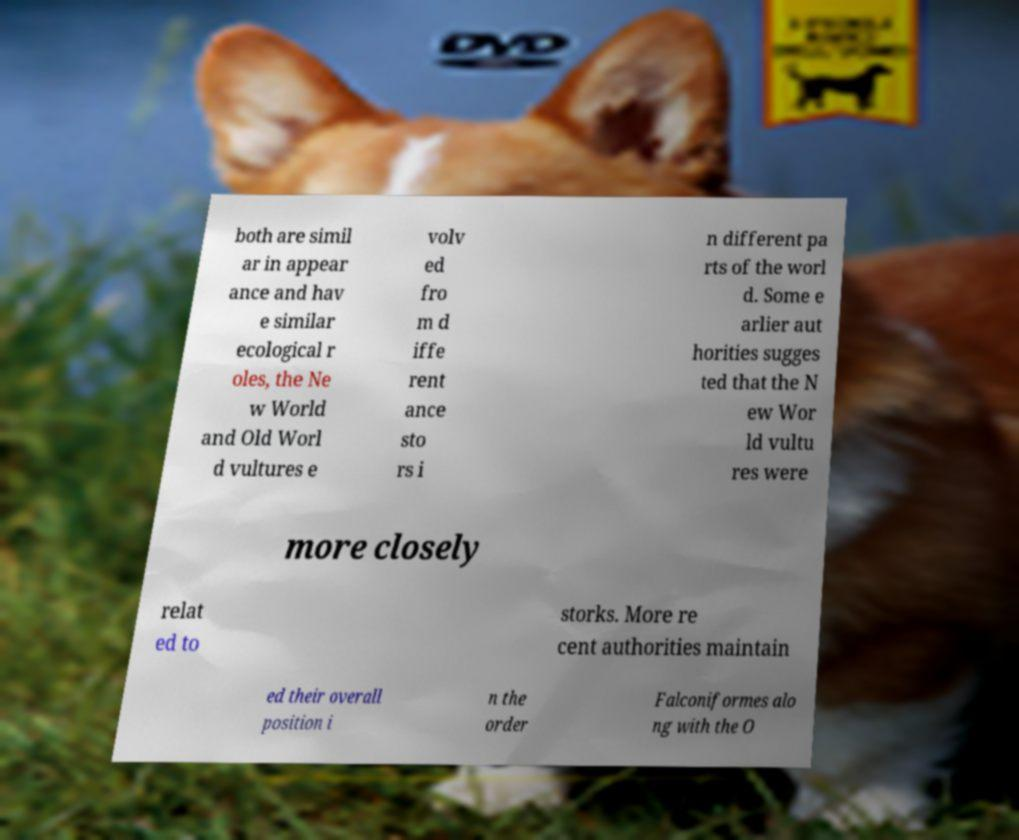Could you extract and type out the text from this image? both are simil ar in appear ance and hav e similar ecological r oles, the Ne w World and Old Worl d vultures e volv ed fro m d iffe rent ance sto rs i n different pa rts of the worl d. Some e arlier aut horities sugges ted that the N ew Wor ld vultu res were more closely relat ed to storks. More re cent authorities maintain ed their overall position i n the order Falconiformes alo ng with the O 